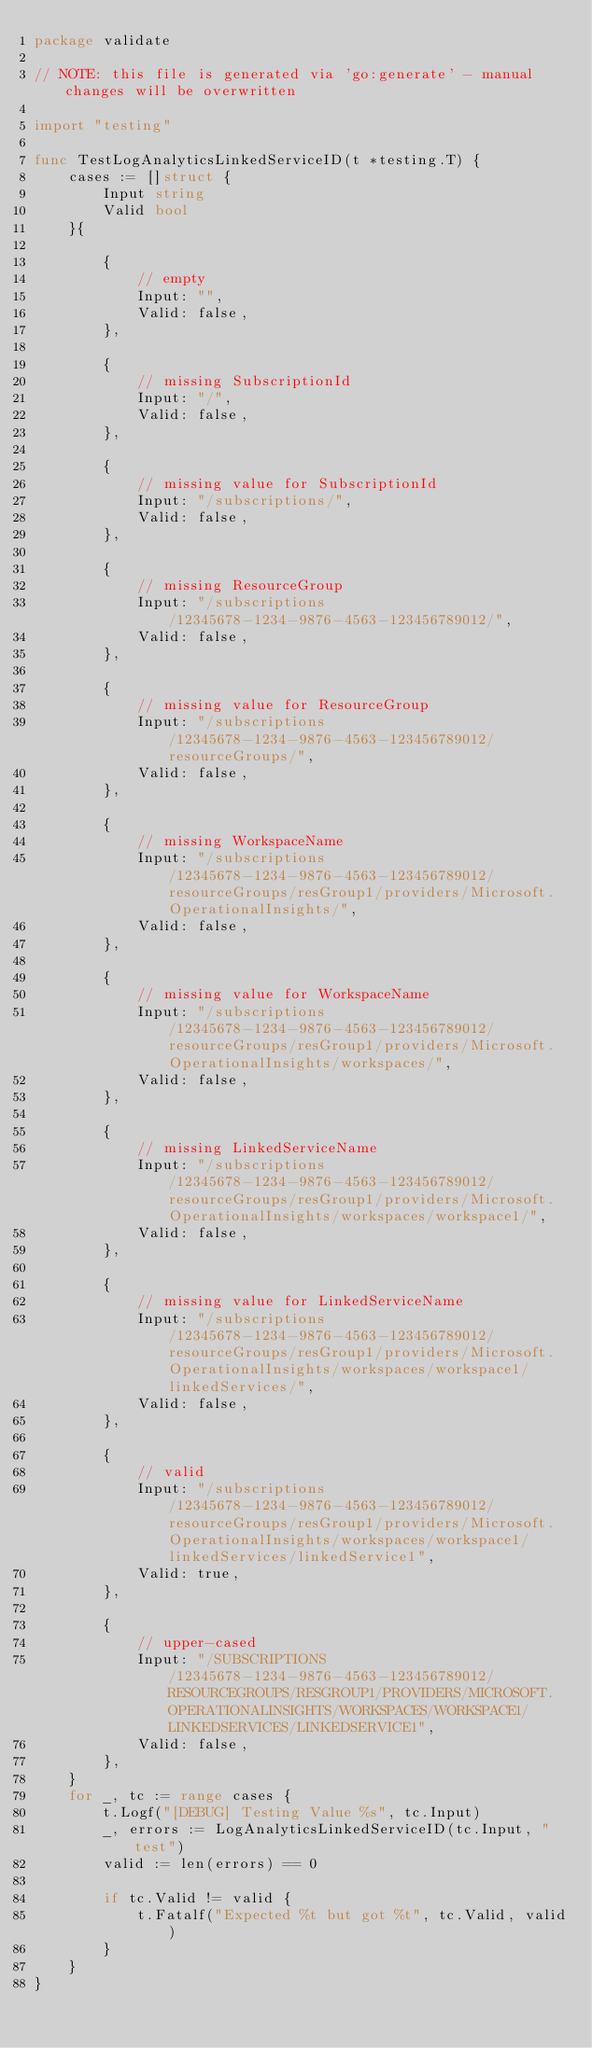Convert code to text. <code><loc_0><loc_0><loc_500><loc_500><_Go_>package validate

// NOTE: this file is generated via 'go:generate' - manual changes will be overwritten

import "testing"

func TestLogAnalyticsLinkedServiceID(t *testing.T) {
	cases := []struct {
		Input string
		Valid bool
	}{

		{
			// empty
			Input: "",
			Valid: false,
		},

		{
			// missing SubscriptionId
			Input: "/",
			Valid: false,
		},

		{
			// missing value for SubscriptionId
			Input: "/subscriptions/",
			Valid: false,
		},

		{
			// missing ResourceGroup
			Input: "/subscriptions/12345678-1234-9876-4563-123456789012/",
			Valid: false,
		},

		{
			// missing value for ResourceGroup
			Input: "/subscriptions/12345678-1234-9876-4563-123456789012/resourceGroups/",
			Valid: false,
		},

		{
			// missing WorkspaceName
			Input: "/subscriptions/12345678-1234-9876-4563-123456789012/resourceGroups/resGroup1/providers/Microsoft.OperationalInsights/",
			Valid: false,
		},

		{
			// missing value for WorkspaceName
			Input: "/subscriptions/12345678-1234-9876-4563-123456789012/resourceGroups/resGroup1/providers/Microsoft.OperationalInsights/workspaces/",
			Valid: false,
		},

		{
			// missing LinkedServiceName
			Input: "/subscriptions/12345678-1234-9876-4563-123456789012/resourceGroups/resGroup1/providers/Microsoft.OperationalInsights/workspaces/workspace1/",
			Valid: false,
		},

		{
			// missing value for LinkedServiceName
			Input: "/subscriptions/12345678-1234-9876-4563-123456789012/resourceGroups/resGroup1/providers/Microsoft.OperationalInsights/workspaces/workspace1/linkedServices/",
			Valid: false,
		},

		{
			// valid
			Input: "/subscriptions/12345678-1234-9876-4563-123456789012/resourceGroups/resGroup1/providers/Microsoft.OperationalInsights/workspaces/workspace1/linkedServices/linkedService1",
			Valid: true,
		},

		{
			// upper-cased
			Input: "/SUBSCRIPTIONS/12345678-1234-9876-4563-123456789012/RESOURCEGROUPS/RESGROUP1/PROVIDERS/MICROSOFT.OPERATIONALINSIGHTS/WORKSPACES/WORKSPACE1/LINKEDSERVICES/LINKEDSERVICE1",
			Valid: false,
		},
	}
	for _, tc := range cases {
		t.Logf("[DEBUG] Testing Value %s", tc.Input)
		_, errors := LogAnalyticsLinkedServiceID(tc.Input, "test")
		valid := len(errors) == 0

		if tc.Valid != valid {
			t.Fatalf("Expected %t but got %t", tc.Valid, valid)
		}
	}
}
</code> 